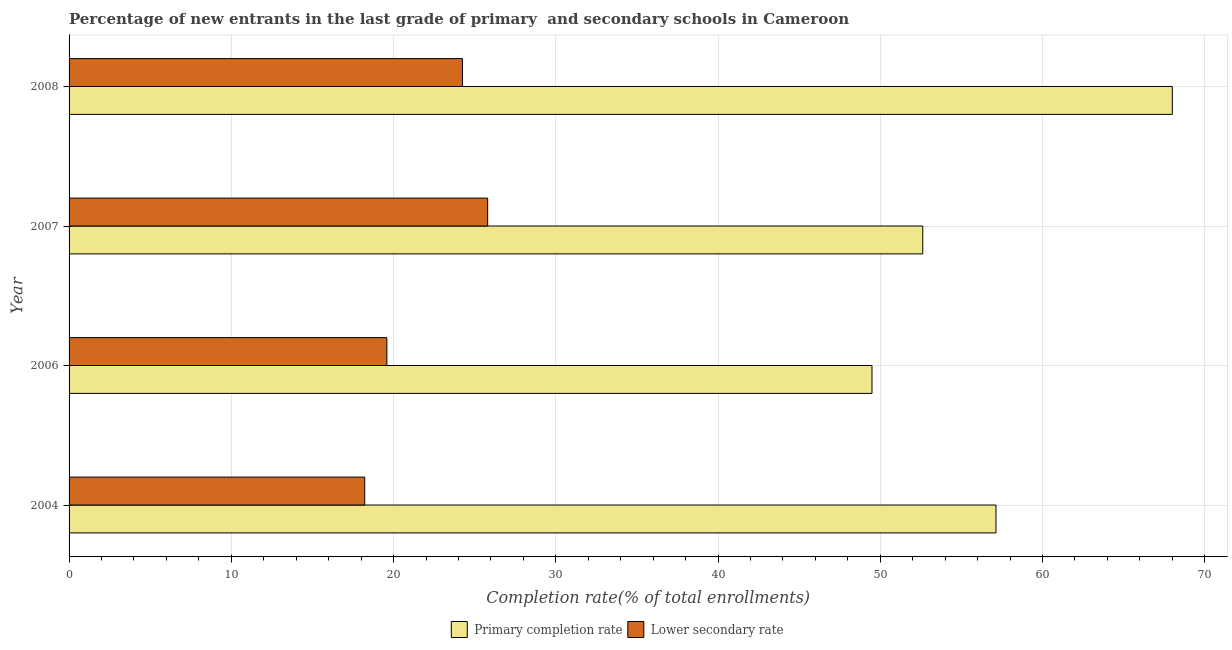Are the number of bars per tick equal to the number of legend labels?
Give a very brief answer. Yes. In how many cases, is the number of bars for a given year not equal to the number of legend labels?
Ensure brevity in your answer.  0. What is the completion rate in secondary schools in 2004?
Keep it short and to the point. 18.22. Across all years, what is the maximum completion rate in primary schools?
Ensure brevity in your answer.  68. Across all years, what is the minimum completion rate in secondary schools?
Your answer should be very brief. 18.22. In which year was the completion rate in secondary schools maximum?
Offer a terse response. 2007. In which year was the completion rate in secondary schools minimum?
Ensure brevity in your answer.  2004. What is the total completion rate in primary schools in the graph?
Your response must be concise. 227.24. What is the difference between the completion rate in primary schools in 2004 and that in 2007?
Provide a succinct answer. 4.51. What is the difference between the completion rate in primary schools in 2006 and the completion rate in secondary schools in 2008?
Provide a short and direct response. 25.24. What is the average completion rate in primary schools per year?
Your answer should be very brief. 56.81. In the year 2008, what is the difference between the completion rate in primary schools and completion rate in secondary schools?
Keep it short and to the point. 43.76. In how many years, is the completion rate in secondary schools greater than 2 %?
Keep it short and to the point. 4. What is the ratio of the completion rate in primary schools in 2004 to that in 2007?
Keep it short and to the point. 1.09. Is the completion rate in secondary schools in 2004 less than that in 2006?
Give a very brief answer. Yes. Is the difference between the completion rate in secondary schools in 2007 and 2008 greater than the difference between the completion rate in primary schools in 2007 and 2008?
Make the answer very short. Yes. What is the difference between the highest and the second highest completion rate in secondary schools?
Your answer should be compact. 1.55. What is the difference between the highest and the lowest completion rate in secondary schools?
Give a very brief answer. 7.58. What does the 2nd bar from the top in 2004 represents?
Ensure brevity in your answer.  Primary completion rate. What does the 1st bar from the bottom in 2006 represents?
Your response must be concise. Primary completion rate. How many bars are there?
Your response must be concise. 8. How many years are there in the graph?
Your response must be concise. 4. Are the values on the major ticks of X-axis written in scientific E-notation?
Make the answer very short. No. Does the graph contain grids?
Provide a short and direct response. Yes. Where does the legend appear in the graph?
Offer a terse response. Bottom center. How many legend labels are there?
Your answer should be compact. 2. What is the title of the graph?
Provide a short and direct response. Percentage of new entrants in the last grade of primary  and secondary schools in Cameroon. What is the label or title of the X-axis?
Your response must be concise. Completion rate(% of total enrollments). What is the Completion rate(% of total enrollments) in Primary completion rate in 2004?
Give a very brief answer. 57.13. What is the Completion rate(% of total enrollments) of Lower secondary rate in 2004?
Provide a short and direct response. 18.22. What is the Completion rate(% of total enrollments) of Primary completion rate in 2006?
Provide a short and direct response. 49.49. What is the Completion rate(% of total enrollments) in Lower secondary rate in 2006?
Offer a terse response. 19.59. What is the Completion rate(% of total enrollments) of Primary completion rate in 2007?
Keep it short and to the point. 52.62. What is the Completion rate(% of total enrollments) in Lower secondary rate in 2007?
Provide a succinct answer. 25.8. What is the Completion rate(% of total enrollments) of Primary completion rate in 2008?
Your answer should be very brief. 68. What is the Completion rate(% of total enrollments) in Lower secondary rate in 2008?
Keep it short and to the point. 24.25. Across all years, what is the maximum Completion rate(% of total enrollments) in Primary completion rate?
Your answer should be compact. 68. Across all years, what is the maximum Completion rate(% of total enrollments) of Lower secondary rate?
Offer a terse response. 25.8. Across all years, what is the minimum Completion rate(% of total enrollments) in Primary completion rate?
Provide a succinct answer. 49.49. Across all years, what is the minimum Completion rate(% of total enrollments) in Lower secondary rate?
Give a very brief answer. 18.22. What is the total Completion rate(% of total enrollments) of Primary completion rate in the graph?
Make the answer very short. 227.24. What is the total Completion rate(% of total enrollments) of Lower secondary rate in the graph?
Your response must be concise. 87.86. What is the difference between the Completion rate(% of total enrollments) of Primary completion rate in 2004 and that in 2006?
Offer a very short reply. 7.64. What is the difference between the Completion rate(% of total enrollments) of Lower secondary rate in 2004 and that in 2006?
Keep it short and to the point. -1.36. What is the difference between the Completion rate(% of total enrollments) of Primary completion rate in 2004 and that in 2007?
Your answer should be very brief. 4.51. What is the difference between the Completion rate(% of total enrollments) in Lower secondary rate in 2004 and that in 2007?
Offer a terse response. -7.58. What is the difference between the Completion rate(% of total enrollments) in Primary completion rate in 2004 and that in 2008?
Provide a succinct answer. -10.87. What is the difference between the Completion rate(% of total enrollments) of Lower secondary rate in 2004 and that in 2008?
Offer a very short reply. -6.02. What is the difference between the Completion rate(% of total enrollments) of Primary completion rate in 2006 and that in 2007?
Ensure brevity in your answer.  -3.13. What is the difference between the Completion rate(% of total enrollments) in Lower secondary rate in 2006 and that in 2007?
Your response must be concise. -6.21. What is the difference between the Completion rate(% of total enrollments) in Primary completion rate in 2006 and that in 2008?
Offer a very short reply. -18.51. What is the difference between the Completion rate(% of total enrollments) of Lower secondary rate in 2006 and that in 2008?
Provide a short and direct response. -4.66. What is the difference between the Completion rate(% of total enrollments) in Primary completion rate in 2007 and that in 2008?
Your answer should be compact. -15.38. What is the difference between the Completion rate(% of total enrollments) of Lower secondary rate in 2007 and that in 2008?
Ensure brevity in your answer.  1.55. What is the difference between the Completion rate(% of total enrollments) of Primary completion rate in 2004 and the Completion rate(% of total enrollments) of Lower secondary rate in 2006?
Give a very brief answer. 37.55. What is the difference between the Completion rate(% of total enrollments) in Primary completion rate in 2004 and the Completion rate(% of total enrollments) in Lower secondary rate in 2007?
Provide a succinct answer. 31.33. What is the difference between the Completion rate(% of total enrollments) in Primary completion rate in 2004 and the Completion rate(% of total enrollments) in Lower secondary rate in 2008?
Give a very brief answer. 32.89. What is the difference between the Completion rate(% of total enrollments) in Primary completion rate in 2006 and the Completion rate(% of total enrollments) in Lower secondary rate in 2007?
Give a very brief answer. 23.69. What is the difference between the Completion rate(% of total enrollments) in Primary completion rate in 2006 and the Completion rate(% of total enrollments) in Lower secondary rate in 2008?
Offer a very short reply. 25.24. What is the difference between the Completion rate(% of total enrollments) of Primary completion rate in 2007 and the Completion rate(% of total enrollments) of Lower secondary rate in 2008?
Your answer should be very brief. 28.37. What is the average Completion rate(% of total enrollments) of Primary completion rate per year?
Offer a very short reply. 56.81. What is the average Completion rate(% of total enrollments) of Lower secondary rate per year?
Your answer should be compact. 21.96. In the year 2004, what is the difference between the Completion rate(% of total enrollments) in Primary completion rate and Completion rate(% of total enrollments) in Lower secondary rate?
Make the answer very short. 38.91. In the year 2006, what is the difference between the Completion rate(% of total enrollments) of Primary completion rate and Completion rate(% of total enrollments) of Lower secondary rate?
Keep it short and to the point. 29.9. In the year 2007, what is the difference between the Completion rate(% of total enrollments) in Primary completion rate and Completion rate(% of total enrollments) in Lower secondary rate?
Make the answer very short. 26.82. In the year 2008, what is the difference between the Completion rate(% of total enrollments) in Primary completion rate and Completion rate(% of total enrollments) in Lower secondary rate?
Your answer should be compact. 43.76. What is the ratio of the Completion rate(% of total enrollments) in Primary completion rate in 2004 to that in 2006?
Offer a terse response. 1.15. What is the ratio of the Completion rate(% of total enrollments) in Lower secondary rate in 2004 to that in 2006?
Make the answer very short. 0.93. What is the ratio of the Completion rate(% of total enrollments) in Primary completion rate in 2004 to that in 2007?
Your response must be concise. 1.09. What is the ratio of the Completion rate(% of total enrollments) in Lower secondary rate in 2004 to that in 2007?
Offer a very short reply. 0.71. What is the ratio of the Completion rate(% of total enrollments) of Primary completion rate in 2004 to that in 2008?
Make the answer very short. 0.84. What is the ratio of the Completion rate(% of total enrollments) in Lower secondary rate in 2004 to that in 2008?
Provide a succinct answer. 0.75. What is the ratio of the Completion rate(% of total enrollments) of Primary completion rate in 2006 to that in 2007?
Provide a short and direct response. 0.94. What is the ratio of the Completion rate(% of total enrollments) in Lower secondary rate in 2006 to that in 2007?
Your answer should be very brief. 0.76. What is the ratio of the Completion rate(% of total enrollments) of Primary completion rate in 2006 to that in 2008?
Your answer should be very brief. 0.73. What is the ratio of the Completion rate(% of total enrollments) of Lower secondary rate in 2006 to that in 2008?
Provide a succinct answer. 0.81. What is the ratio of the Completion rate(% of total enrollments) in Primary completion rate in 2007 to that in 2008?
Make the answer very short. 0.77. What is the ratio of the Completion rate(% of total enrollments) of Lower secondary rate in 2007 to that in 2008?
Give a very brief answer. 1.06. What is the difference between the highest and the second highest Completion rate(% of total enrollments) of Primary completion rate?
Provide a short and direct response. 10.87. What is the difference between the highest and the second highest Completion rate(% of total enrollments) in Lower secondary rate?
Your answer should be compact. 1.55. What is the difference between the highest and the lowest Completion rate(% of total enrollments) of Primary completion rate?
Make the answer very short. 18.51. What is the difference between the highest and the lowest Completion rate(% of total enrollments) of Lower secondary rate?
Give a very brief answer. 7.58. 